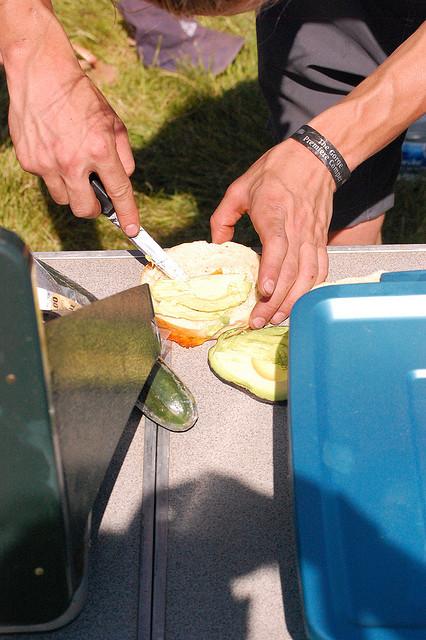What utensil is being used?
Give a very brief answer. Knife. Is this person inside or outside?
Concise answer only. Outside. What is on the person's wrist?
Keep it brief. Bracelet. Can I put the blue plates in the dishwasher?
Short answer required. Yes. 